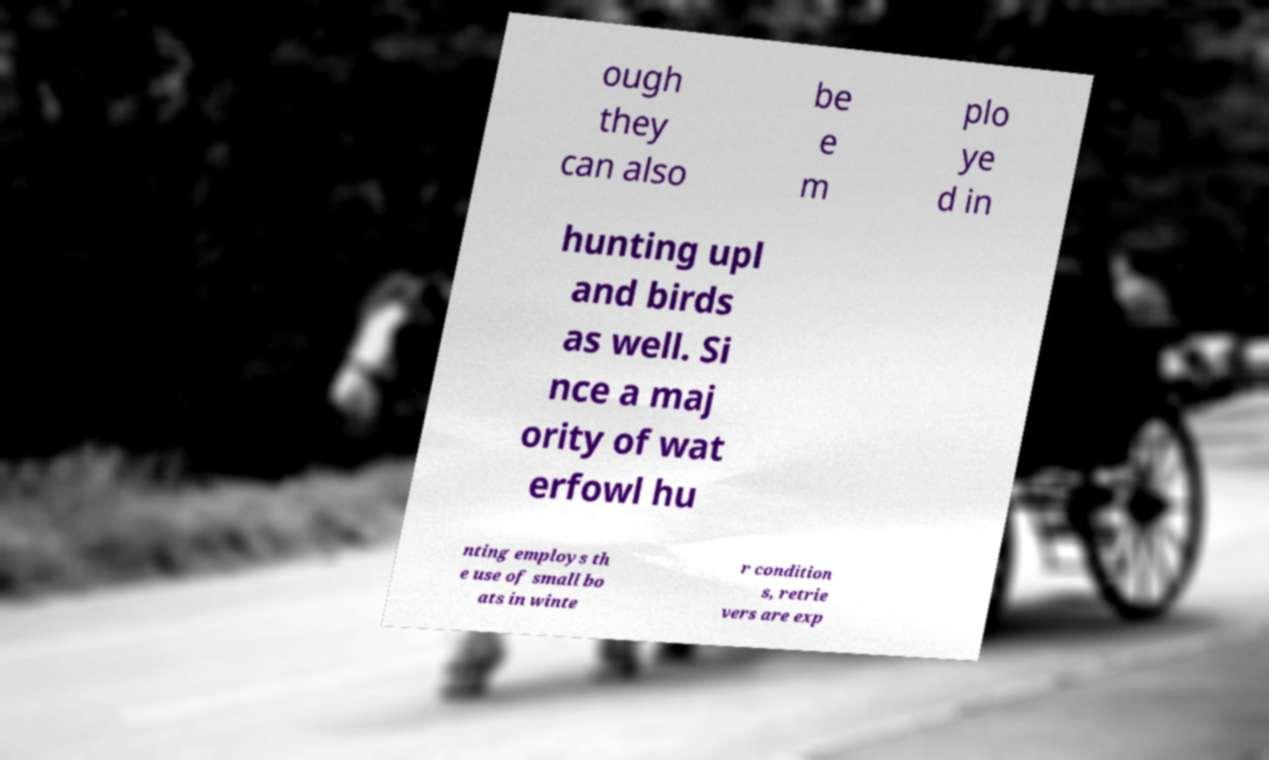I need the written content from this picture converted into text. Can you do that? ough they can also be e m plo ye d in hunting upl and birds as well. Si nce a maj ority of wat erfowl hu nting employs th e use of small bo ats in winte r condition s, retrie vers are exp 